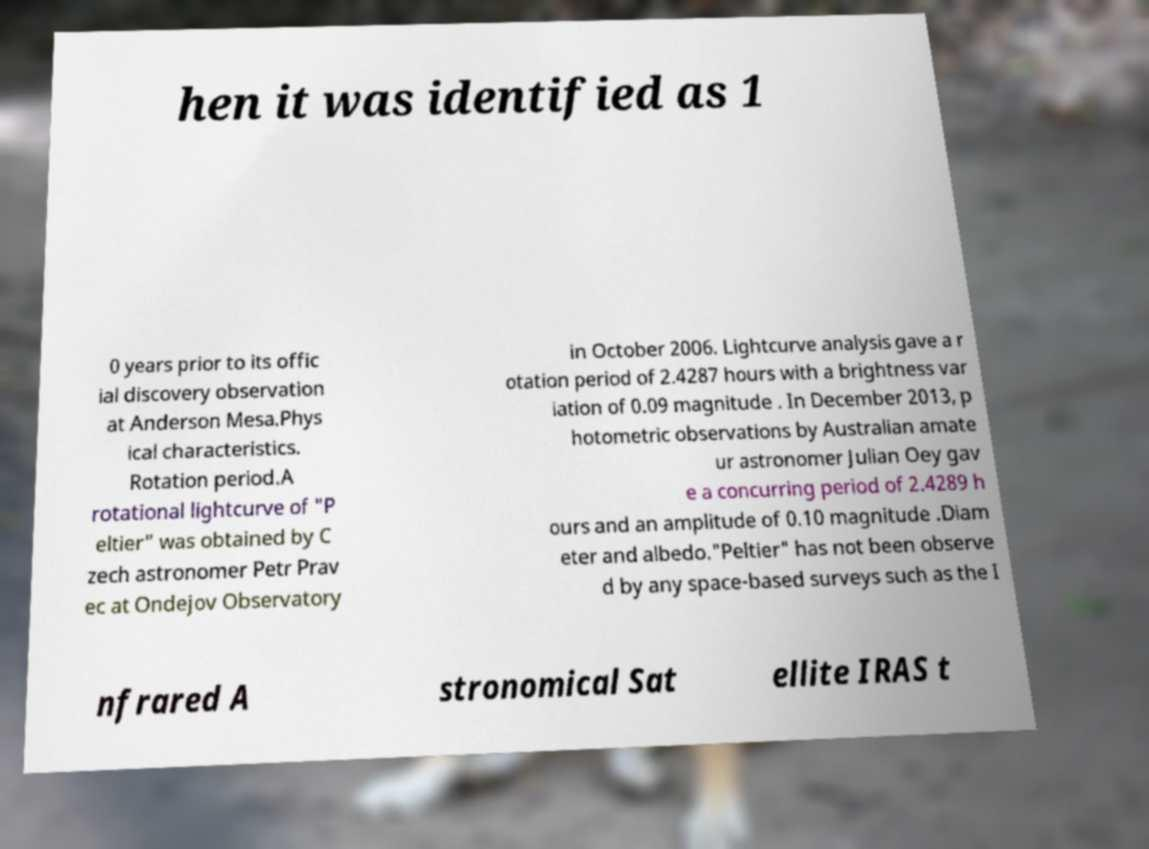There's text embedded in this image that I need extracted. Can you transcribe it verbatim? hen it was identified as 1 0 years prior to its offic ial discovery observation at Anderson Mesa.Phys ical characteristics. Rotation period.A rotational lightcurve of "P eltier" was obtained by C zech astronomer Petr Prav ec at Ondejov Observatory in October 2006. Lightcurve analysis gave a r otation period of 2.4287 hours with a brightness var iation of 0.09 magnitude . In December 2013, p hotometric observations by Australian amate ur astronomer Julian Oey gav e a concurring period of 2.4289 h ours and an amplitude of 0.10 magnitude .Diam eter and albedo."Peltier" has not been observe d by any space-based surveys such as the I nfrared A stronomical Sat ellite IRAS t 